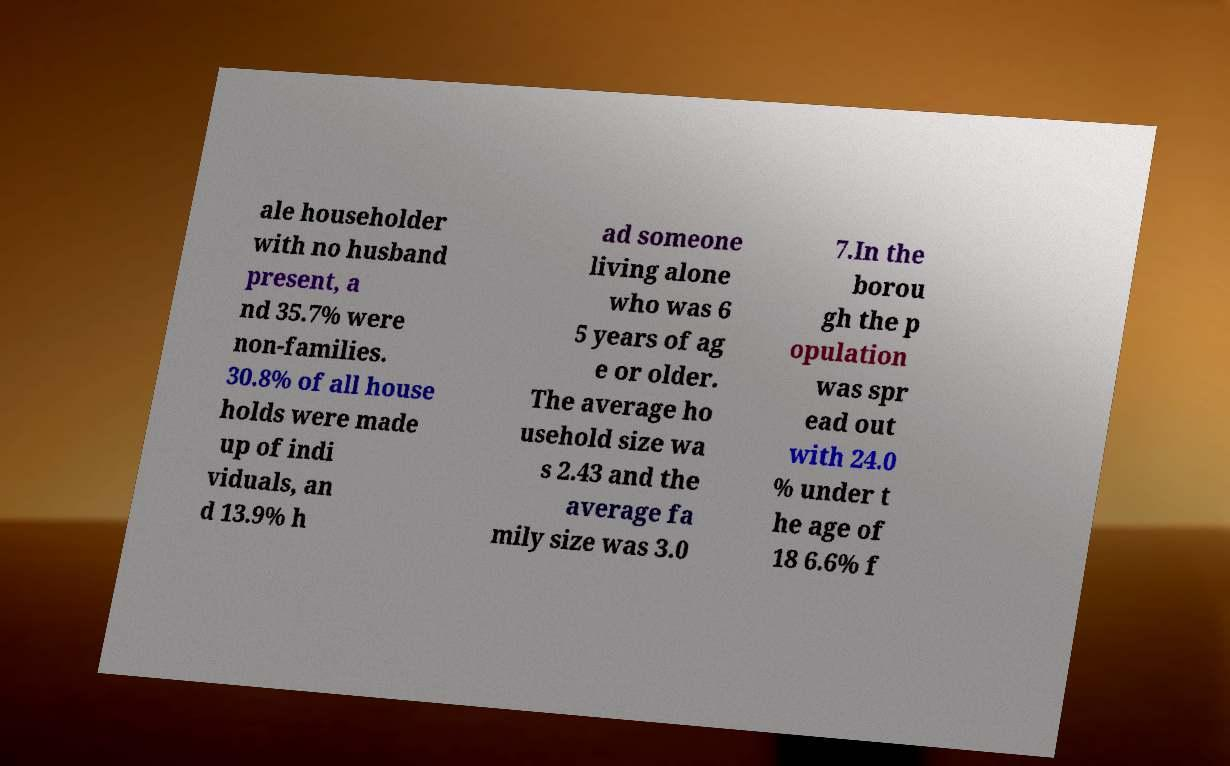Can you read and provide the text displayed in the image?This photo seems to have some interesting text. Can you extract and type it out for me? ale householder with no husband present, a nd 35.7% were non-families. 30.8% of all house holds were made up of indi viduals, an d 13.9% h ad someone living alone who was 6 5 years of ag e or older. The average ho usehold size wa s 2.43 and the average fa mily size was 3.0 7.In the borou gh the p opulation was spr ead out with 24.0 % under t he age of 18 6.6% f 